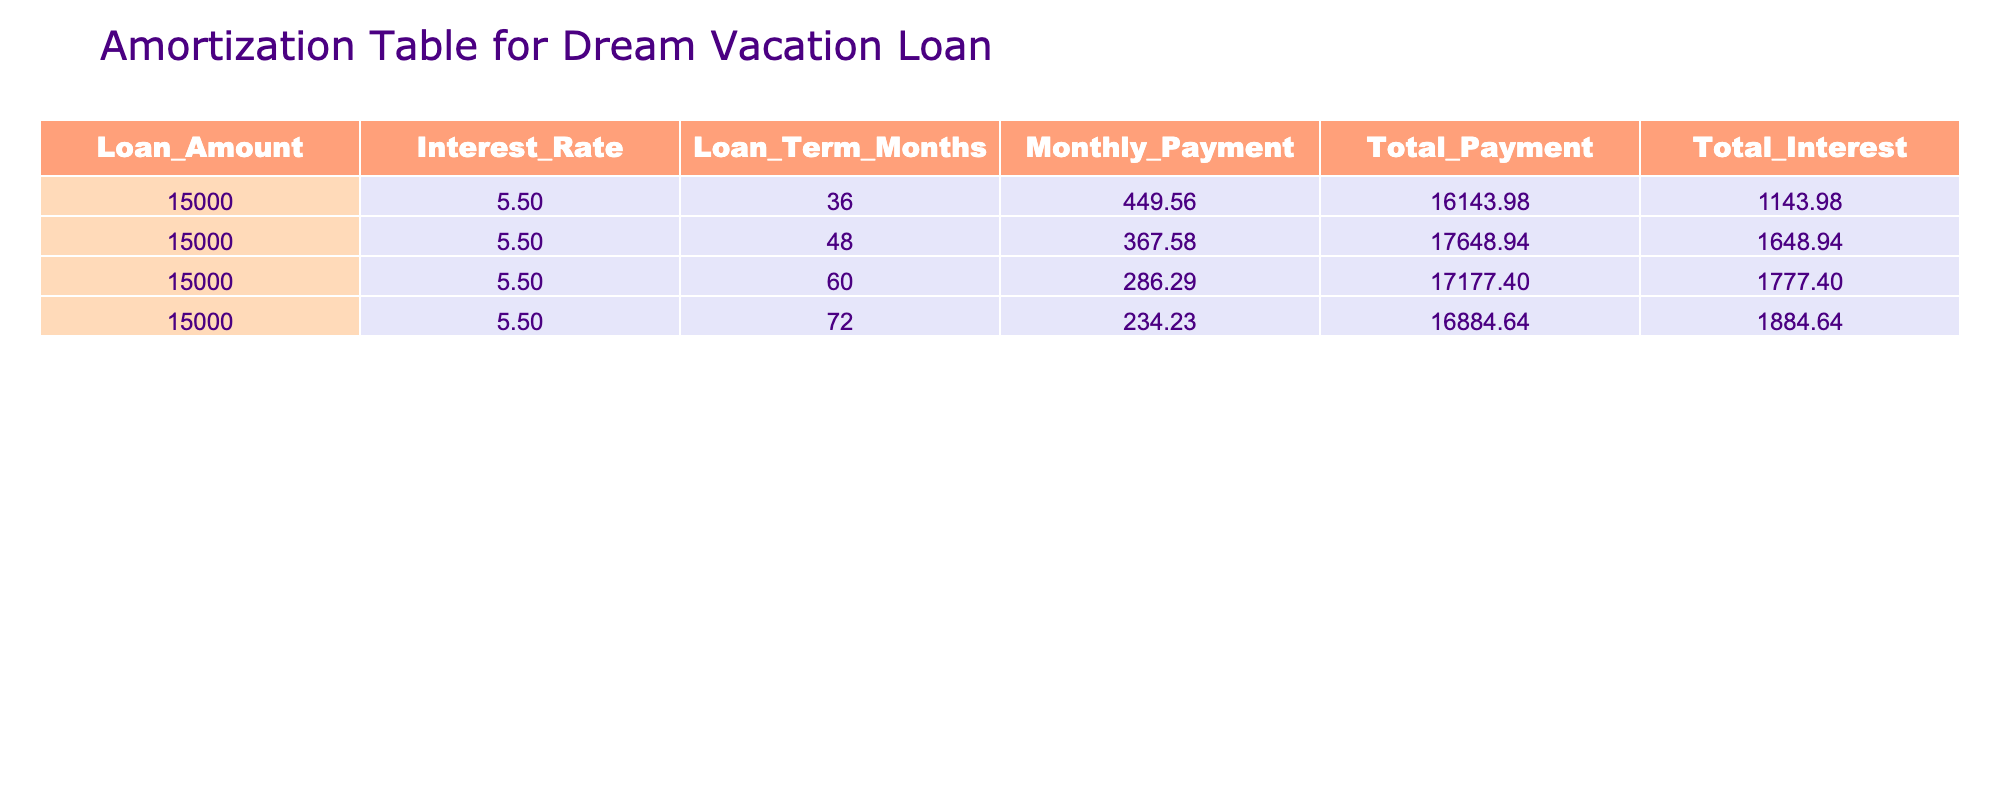What is the monthly payment for the loan over 60 months? The table shows a specific monthly payment value for a loan term of 60 months, which is provided directly in the "Monthly_Payment" column. According to the table, the monthly payment is 286.29.
Answer: 286.29 What is the total interest paid if the loan is taken for 48 months? The total interest paid for a loan term of 48 months can be found directly in the "Total_Interest" column corresponding to that term. According to the table, the total interest for a 48-month term is 1648.94.
Answer: 1648.94 How much more is the total payment for a 36-month loan compared to a 72-month loan? To find the difference in total payments, we need to first identify the total payments for both the 36-month and 72-month terms from the "Total_Payment" column. For 36 months, the total payment is 16143.98, and for 72 months, it is 16884.64. We then subtract the latter from the former: 16884.64 - 16143.98 = 740.66.
Answer: 740.66 Is the total payment for the 60-month term less than the total payment for the 48-month term? We compare the values in the "Total_Payment" column for 60 and 48 months. The total payment for 60 months is 17177.40 and for 48 months is 17648.94. Since 17177.40 is less than 17648.94, the answer is yes.
Answer: Yes What is the average monthly payment across all loan terms? To calculate the average monthly payment, we will first sum the monthly payments from all rows: 449.56 + 367.58 + 286.29 + 234.23 = 1337.66. There are four loan terms, so we divide the total by 4: 1337.66 / 4 = 334.42.
Answer: 334.42 Which loan term has the highest total interest paid? We can compare the "Total_Interest" values across all loan terms. The values are 1143.98, 1648.94, 1777.40, and 1884.64 for 36, 48, 60, and 72 months respectively. The highest is 1884.64 associated with the 72-month term.
Answer: 72 months (1884.64) What is the difference in loan amounts for the two longest loan terms? Since all loan amounts are the same in this table, we will check the values associated with the 60-month and 72-month terms, which are both 15000. Thus, the difference is 15000 - 15000 = 0.
Answer: 0 Is the monthly payment for the 72-month term less than for the 36-month term? We look at the monthly payments in the table: for 72 months, the payment is 234.23 and for 36 months, it is 449.56. Since 234.23 is less than 449.56, the answer is yes.
Answer: Yes 